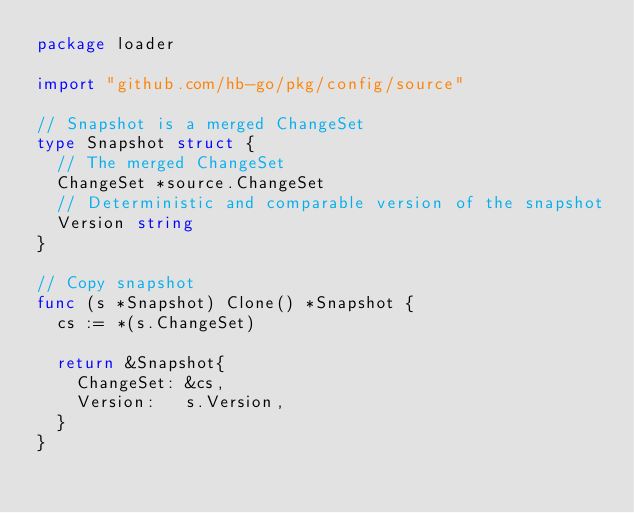<code> <loc_0><loc_0><loc_500><loc_500><_Go_>package loader

import "github.com/hb-go/pkg/config/source"

// Snapshot is a merged ChangeSet
type Snapshot struct {
	// The merged ChangeSet
	ChangeSet *source.ChangeSet
	// Deterministic and comparable version of the snapshot
	Version string
}

// Copy snapshot
func (s *Snapshot) Clone() *Snapshot {
	cs := *(s.ChangeSet)

	return &Snapshot{
		ChangeSet: &cs,
		Version:   s.Version,
	}
}
</code> 